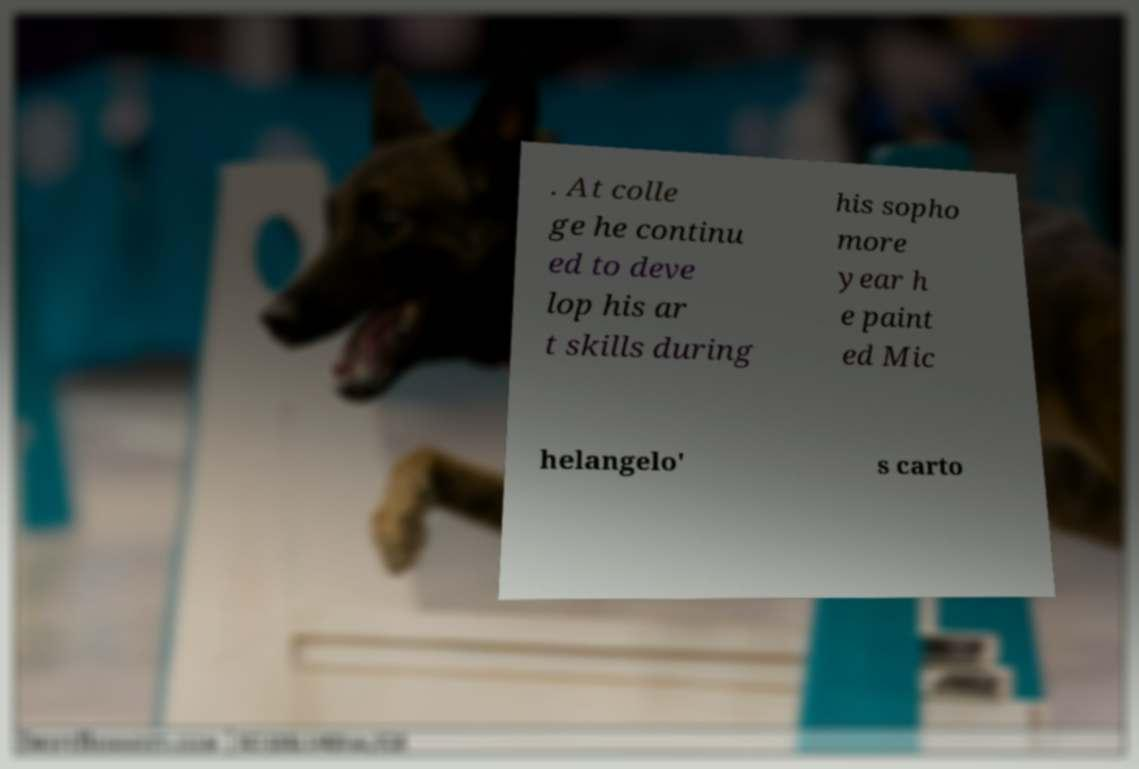Could you assist in decoding the text presented in this image and type it out clearly? . At colle ge he continu ed to deve lop his ar t skills during his sopho more year h e paint ed Mic helangelo' s carto 